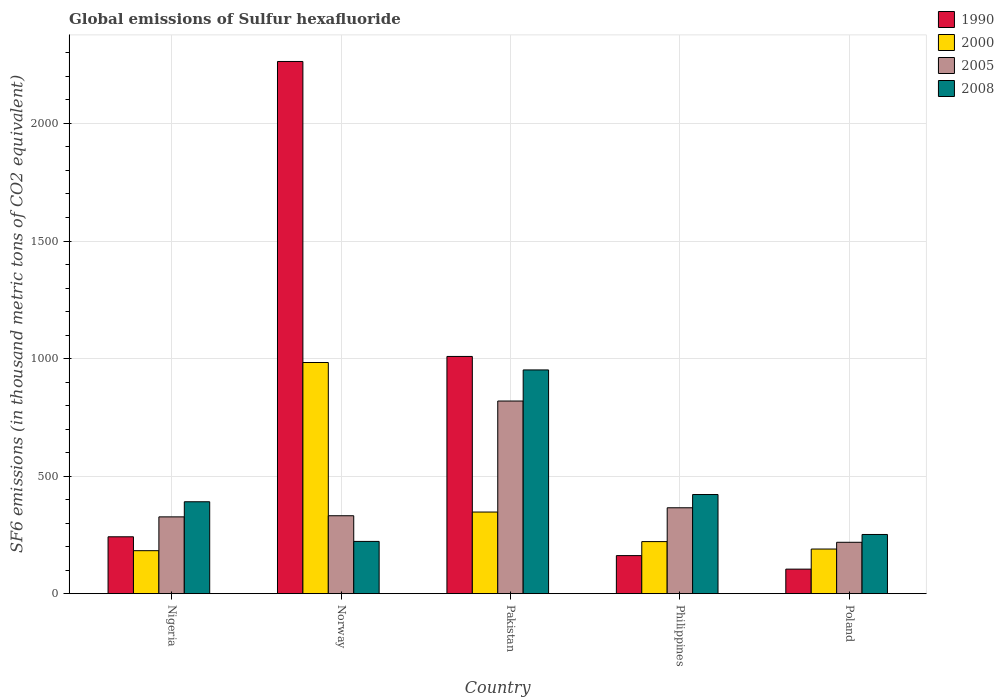How many different coloured bars are there?
Ensure brevity in your answer.  4. How many groups of bars are there?
Your response must be concise. 5. Are the number of bars per tick equal to the number of legend labels?
Give a very brief answer. Yes. Are the number of bars on each tick of the X-axis equal?
Ensure brevity in your answer.  Yes. How many bars are there on the 1st tick from the right?
Give a very brief answer. 4. What is the label of the 4th group of bars from the left?
Give a very brief answer. Philippines. What is the global emissions of Sulfur hexafluoride in 2000 in Pakistan?
Your response must be concise. 347.2. Across all countries, what is the maximum global emissions of Sulfur hexafluoride in 2008?
Make the answer very short. 951.6. Across all countries, what is the minimum global emissions of Sulfur hexafluoride in 1990?
Your answer should be compact. 104.3. In which country was the global emissions of Sulfur hexafluoride in 2000 minimum?
Make the answer very short. Nigeria. What is the total global emissions of Sulfur hexafluoride in 2005 in the graph?
Provide a short and direct response. 2061.2. What is the difference between the global emissions of Sulfur hexafluoride in 2000 in Nigeria and that in Norway?
Your response must be concise. -800.4. What is the difference between the global emissions of Sulfur hexafluoride in 2000 in Poland and the global emissions of Sulfur hexafluoride in 1990 in Philippines?
Provide a short and direct response. 27.9. What is the average global emissions of Sulfur hexafluoride in 2000 per country?
Your response must be concise. 384.88. What is the difference between the global emissions of Sulfur hexafluoride of/in 2005 and global emissions of Sulfur hexafluoride of/in 2000 in Nigeria?
Offer a terse response. 143.8. In how many countries, is the global emissions of Sulfur hexafluoride in 2008 greater than 200 thousand metric tons?
Make the answer very short. 5. What is the ratio of the global emissions of Sulfur hexafluoride in 2005 in Pakistan to that in Philippines?
Ensure brevity in your answer.  2.24. Is the global emissions of Sulfur hexafluoride in 1990 in Nigeria less than that in Poland?
Give a very brief answer. No. What is the difference between the highest and the second highest global emissions of Sulfur hexafluoride in 2005?
Your answer should be compact. -488. What is the difference between the highest and the lowest global emissions of Sulfur hexafluoride in 2000?
Your response must be concise. 800.4. In how many countries, is the global emissions of Sulfur hexafluoride in 1990 greater than the average global emissions of Sulfur hexafluoride in 1990 taken over all countries?
Offer a terse response. 2. Is the sum of the global emissions of Sulfur hexafluoride in 1990 in Norway and Philippines greater than the maximum global emissions of Sulfur hexafluoride in 2000 across all countries?
Give a very brief answer. Yes. Is it the case that in every country, the sum of the global emissions of Sulfur hexafluoride in 2005 and global emissions of Sulfur hexafluoride in 1990 is greater than the sum of global emissions of Sulfur hexafluoride in 2008 and global emissions of Sulfur hexafluoride in 2000?
Your response must be concise. No. What does the 2nd bar from the left in Poland represents?
Keep it short and to the point. 2000. What does the 4th bar from the right in Philippines represents?
Provide a succinct answer. 1990. Is it the case that in every country, the sum of the global emissions of Sulfur hexafluoride in 2005 and global emissions of Sulfur hexafluoride in 2000 is greater than the global emissions of Sulfur hexafluoride in 1990?
Give a very brief answer. No. How many bars are there?
Offer a terse response. 20. Does the graph contain grids?
Offer a terse response. Yes. What is the title of the graph?
Offer a terse response. Global emissions of Sulfur hexafluoride. What is the label or title of the Y-axis?
Keep it short and to the point. SF6 emissions (in thousand metric tons of CO2 equivalent). What is the SF6 emissions (in thousand metric tons of CO2 equivalent) of 1990 in Nigeria?
Provide a succinct answer. 241.9. What is the SF6 emissions (in thousand metric tons of CO2 equivalent) of 2000 in Nigeria?
Provide a succinct answer. 182.8. What is the SF6 emissions (in thousand metric tons of CO2 equivalent) in 2005 in Nigeria?
Your answer should be very brief. 326.6. What is the SF6 emissions (in thousand metric tons of CO2 equivalent) in 2008 in Nigeria?
Provide a succinct answer. 390.9. What is the SF6 emissions (in thousand metric tons of CO2 equivalent) of 1990 in Norway?
Provide a short and direct response. 2263.6. What is the SF6 emissions (in thousand metric tons of CO2 equivalent) in 2000 in Norway?
Your response must be concise. 983.2. What is the SF6 emissions (in thousand metric tons of CO2 equivalent) of 2005 in Norway?
Offer a very short reply. 331.4. What is the SF6 emissions (in thousand metric tons of CO2 equivalent) in 2008 in Norway?
Provide a short and direct response. 222.2. What is the SF6 emissions (in thousand metric tons of CO2 equivalent) of 1990 in Pakistan?
Make the answer very short. 1009. What is the SF6 emissions (in thousand metric tons of CO2 equivalent) in 2000 in Pakistan?
Ensure brevity in your answer.  347.2. What is the SF6 emissions (in thousand metric tons of CO2 equivalent) of 2005 in Pakistan?
Provide a short and direct response. 819.4. What is the SF6 emissions (in thousand metric tons of CO2 equivalent) in 2008 in Pakistan?
Provide a succinct answer. 951.6. What is the SF6 emissions (in thousand metric tons of CO2 equivalent) of 1990 in Philippines?
Ensure brevity in your answer.  161.9. What is the SF6 emissions (in thousand metric tons of CO2 equivalent) of 2000 in Philippines?
Keep it short and to the point. 221.4. What is the SF6 emissions (in thousand metric tons of CO2 equivalent) of 2005 in Philippines?
Provide a succinct answer. 365.3. What is the SF6 emissions (in thousand metric tons of CO2 equivalent) of 2008 in Philippines?
Give a very brief answer. 421.7. What is the SF6 emissions (in thousand metric tons of CO2 equivalent) in 1990 in Poland?
Your response must be concise. 104.3. What is the SF6 emissions (in thousand metric tons of CO2 equivalent) in 2000 in Poland?
Make the answer very short. 189.8. What is the SF6 emissions (in thousand metric tons of CO2 equivalent) in 2005 in Poland?
Your response must be concise. 218.5. What is the SF6 emissions (in thousand metric tons of CO2 equivalent) in 2008 in Poland?
Your answer should be very brief. 251.7. Across all countries, what is the maximum SF6 emissions (in thousand metric tons of CO2 equivalent) in 1990?
Keep it short and to the point. 2263.6. Across all countries, what is the maximum SF6 emissions (in thousand metric tons of CO2 equivalent) of 2000?
Keep it short and to the point. 983.2. Across all countries, what is the maximum SF6 emissions (in thousand metric tons of CO2 equivalent) of 2005?
Your answer should be compact. 819.4. Across all countries, what is the maximum SF6 emissions (in thousand metric tons of CO2 equivalent) in 2008?
Ensure brevity in your answer.  951.6. Across all countries, what is the minimum SF6 emissions (in thousand metric tons of CO2 equivalent) of 1990?
Your answer should be compact. 104.3. Across all countries, what is the minimum SF6 emissions (in thousand metric tons of CO2 equivalent) of 2000?
Offer a terse response. 182.8. Across all countries, what is the minimum SF6 emissions (in thousand metric tons of CO2 equivalent) of 2005?
Ensure brevity in your answer.  218.5. Across all countries, what is the minimum SF6 emissions (in thousand metric tons of CO2 equivalent) in 2008?
Give a very brief answer. 222.2. What is the total SF6 emissions (in thousand metric tons of CO2 equivalent) of 1990 in the graph?
Provide a short and direct response. 3780.7. What is the total SF6 emissions (in thousand metric tons of CO2 equivalent) in 2000 in the graph?
Make the answer very short. 1924.4. What is the total SF6 emissions (in thousand metric tons of CO2 equivalent) of 2005 in the graph?
Provide a succinct answer. 2061.2. What is the total SF6 emissions (in thousand metric tons of CO2 equivalent) in 2008 in the graph?
Provide a succinct answer. 2238.1. What is the difference between the SF6 emissions (in thousand metric tons of CO2 equivalent) in 1990 in Nigeria and that in Norway?
Offer a terse response. -2021.7. What is the difference between the SF6 emissions (in thousand metric tons of CO2 equivalent) of 2000 in Nigeria and that in Norway?
Your response must be concise. -800.4. What is the difference between the SF6 emissions (in thousand metric tons of CO2 equivalent) in 2008 in Nigeria and that in Norway?
Provide a succinct answer. 168.7. What is the difference between the SF6 emissions (in thousand metric tons of CO2 equivalent) in 1990 in Nigeria and that in Pakistan?
Keep it short and to the point. -767.1. What is the difference between the SF6 emissions (in thousand metric tons of CO2 equivalent) of 2000 in Nigeria and that in Pakistan?
Offer a very short reply. -164.4. What is the difference between the SF6 emissions (in thousand metric tons of CO2 equivalent) in 2005 in Nigeria and that in Pakistan?
Make the answer very short. -492.8. What is the difference between the SF6 emissions (in thousand metric tons of CO2 equivalent) of 2008 in Nigeria and that in Pakistan?
Offer a terse response. -560.7. What is the difference between the SF6 emissions (in thousand metric tons of CO2 equivalent) of 1990 in Nigeria and that in Philippines?
Your response must be concise. 80. What is the difference between the SF6 emissions (in thousand metric tons of CO2 equivalent) in 2000 in Nigeria and that in Philippines?
Ensure brevity in your answer.  -38.6. What is the difference between the SF6 emissions (in thousand metric tons of CO2 equivalent) in 2005 in Nigeria and that in Philippines?
Offer a terse response. -38.7. What is the difference between the SF6 emissions (in thousand metric tons of CO2 equivalent) in 2008 in Nigeria and that in Philippines?
Your answer should be compact. -30.8. What is the difference between the SF6 emissions (in thousand metric tons of CO2 equivalent) in 1990 in Nigeria and that in Poland?
Keep it short and to the point. 137.6. What is the difference between the SF6 emissions (in thousand metric tons of CO2 equivalent) in 2005 in Nigeria and that in Poland?
Your answer should be compact. 108.1. What is the difference between the SF6 emissions (in thousand metric tons of CO2 equivalent) of 2008 in Nigeria and that in Poland?
Offer a very short reply. 139.2. What is the difference between the SF6 emissions (in thousand metric tons of CO2 equivalent) in 1990 in Norway and that in Pakistan?
Your answer should be very brief. 1254.6. What is the difference between the SF6 emissions (in thousand metric tons of CO2 equivalent) of 2000 in Norway and that in Pakistan?
Keep it short and to the point. 636. What is the difference between the SF6 emissions (in thousand metric tons of CO2 equivalent) in 2005 in Norway and that in Pakistan?
Make the answer very short. -488. What is the difference between the SF6 emissions (in thousand metric tons of CO2 equivalent) in 2008 in Norway and that in Pakistan?
Your answer should be compact. -729.4. What is the difference between the SF6 emissions (in thousand metric tons of CO2 equivalent) of 1990 in Norway and that in Philippines?
Keep it short and to the point. 2101.7. What is the difference between the SF6 emissions (in thousand metric tons of CO2 equivalent) in 2000 in Norway and that in Philippines?
Offer a very short reply. 761.8. What is the difference between the SF6 emissions (in thousand metric tons of CO2 equivalent) of 2005 in Norway and that in Philippines?
Keep it short and to the point. -33.9. What is the difference between the SF6 emissions (in thousand metric tons of CO2 equivalent) in 2008 in Norway and that in Philippines?
Your response must be concise. -199.5. What is the difference between the SF6 emissions (in thousand metric tons of CO2 equivalent) in 1990 in Norway and that in Poland?
Your response must be concise. 2159.3. What is the difference between the SF6 emissions (in thousand metric tons of CO2 equivalent) in 2000 in Norway and that in Poland?
Make the answer very short. 793.4. What is the difference between the SF6 emissions (in thousand metric tons of CO2 equivalent) of 2005 in Norway and that in Poland?
Offer a terse response. 112.9. What is the difference between the SF6 emissions (in thousand metric tons of CO2 equivalent) in 2008 in Norway and that in Poland?
Give a very brief answer. -29.5. What is the difference between the SF6 emissions (in thousand metric tons of CO2 equivalent) in 1990 in Pakistan and that in Philippines?
Your response must be concise. 847.1. What is the difference between the SF6 emissions (in thousand metric tons of CO2 equivalent) in 2000 in Pakistan and that in Philippines?
Offer a very short reply. 125.8. What is the difference between the SF6 emissions (in thousand metric tons of CO2 equivalent) in 2005 in Pakistan and that in Philippines?
Make the answer very short. 454.1. What is the difference between the SF6 emissions (in thousand metric tons of CO2 equivalent) in 2008 in Pakistan and that in Philippines?
Offer a terse response. 529.9. What is the difference between the SF6 emissions (in thousand metric tons of CO2 equivalent) in 1990 in Pakistan and that in Poland?
Your answer should be very brief. 904.7. What is the difference between the SF6 emissions (in thousand metric tons of CO2 equivalent) of 2000 in Pakistan and that in Poland?
Offer a very short reply. 157.4. What is the difference between the SF6 emissions (in thousand metric tons of CO2 equivalent) of 2005 in Pakistan and that in Poland?
Provide a succinct answer. 600.9. What is the difference between the SF6 emissions (in thousand metric tons of CO2 equivalent) of 2008 in Pakistan and that in Poland?
Provide a succinct answer. 699.9. What is the difference between the SF6 emissions (in thousand metric tons of CO2 equivalent) in 1990 in Philippines and that in Poland?
Give a very brief answer. 57.6. What is the difference between the SF6 emissions (in thousand metric tons of CO2 equivalent) of 2000 in Philippines and that in Poland?
Ensure brevity in your answer.  31.6. What is the difference between the SF6 emissions (in thousand metric tons of CO2 equivalent) in 2005 in Philippines and that in Poland?
Offer a very short reply. 146.8. What is the difference between the SF6 emissions (in thousand metric tons of CO2 equivalent) of 2008 in Philippines and that in Poland?
Keep it short and to the point. 170. What is the difference between the SF6 emissions (in thousand metric tons of CO2 equivalent) of 1990 in Nigeria and the SF6 emissions (in thousand metric tons of CO2 equivalent) of 2000 in Norway?
Give a very brief answer. -741.3. What is the difference between the SF6 emissions (in thousand metric tons of CO2 equivalent) of 1990 in Nigeria and the SF6 emissions (in thousand metric tons of CO2 equivalent) of 2005 in Norway?
Your response must be concise. -89.5. What is the difference between the SF6 emissions (in thousand metric tons of CO2 equivalent) of 2000 in Nigeria and the SF6 emissions (in thousand metric tons of CO2 equivalent) of 2005 in Norway?
Your answer should be compact. -148.6. What is the difference between the SF6 emissions (in thousand metric tons of CO2 equivalent) of 2000 in Nigeria and the SF6 emissions (in thousand metric tons of CO2 equivalent) of 2008 in Norway?
Offer a very short reply. -39.4. What is the difference between the SF6 emissions (in thousand metric tons of CO2 equivalent) of 2005 in Nigeria and the SF6 emissions (in thousand metric tons of CO2 equivalent) of 2008 in Norway?
Your answer should be very brief. 104.4. What is the difference between the SF6 emissions (in thousand metric tons of CO2 equivalent) in 1990 in Nigeria and the SF6 emissions (in thousand metric tons of CO2 equivalent) in 2000 in Pakistan?
Provide a succinct answer. -105.3. What is the difference between the SF6 emissions (in thousand metric tons of CO2 equivalent) of 1990 in Nigeria and the SF6 emissions (in thousand metric tons of CO2 equivalent) of 2005 in Pakistan?
Ensure brevity in your answer.  -577.5. What is the difference between the SF6 emissions (in thousand metric tons of CO2 equivalent) of 1990 in Nigeria and the SF6 emissions (in thousand metric tons of CO2 equivalent) of 2008 in Pakistan?
Make the answer very short. -709.7. What is the difference between the SF6 emissions (in thousand metric tons of CO2 equivalent) of 2000 in Nigeria and the SF6 emissions (in thousand metric tons of CO2 equivalent) of 2005 in Pakistan?
Your answer should be very brief. -636.6. What is the difference between the SF6 emissions (in thousand metric tons of CO2 equivalent) in 2000 in Nigeria and the SF6 emissions (in thousand metric tons of CO2 equivalent) in 2008 in Pakistan?
Your answer should be very brief. -768.8. What is the difference between the SF6 emissions (in thousand metric tons of CO2 equivalent) of 2005 in Nigeria and the SF6 emissions (in thousand metric tons of CO2 equivalent) of 2008 in Pakistan?
Keep it short and to the point. -625. What is the difference between the SF6 emissions (in thousand metric tons of CO2 equivalent) in 1990 in Nigeria and the SF6 emissions (in thousand metric tons of CO2 equivalent) in 2005 in Philippines?
Provide a succinct answer. -123.4. What is the difference between the SF6 emissions (in thousand metric tons of CO2 equivalent) of 1990 in Nigeria and the SF6 emissions (in thousand metric tons of CO2 equivalent) of 2008 in Philippines?
Provide a short and direct response. -179.8. What is the difference between the SF6 emissions (in thousand metric tons of CO2 equivalent) of 2000 in Nigeria and the SF6 emissions (in thousand metric tons of CO2 equivalent) of 2005 in Philippines?
Offer a very short reply. -182.5. What is the difference between the SF6 emissions (in thousand metric tons of CO2 equivalent) in 2000 in Nigeria and the SF6 emissions (in thousand metric tons of CO2 equivalent) in 2008 in Philippines?
Offer a terse response. -238.9. What is the difference between the SF6 emissions (in thousand metric tons of CO2 equivalent) in 2005 in Nigeria and the SF6 emissions (in thousand metric tons of CO2 equivalent) in 2008 in Philippines?
Your response must be concise. -95.1. What is the difference between the SF6 emissions (in thousand metric tons of CO2 equivalent) in 1990 in Nigeria and the SF6 emissions (in thousand metric tons of CO2 equivalent) in 2000 in Poland?
Provide a short and direct response. 52.1. What is the difference between the SF6 emissions (in thousand metric tons of CO2 equivalent) in 1990 in Nigeria and the SF6 emissions (in thousand metric tons of CO2 equivalent) in 2005 in Poland?
Ensure brevity in your answer.  23.4. What is the difference between the SF6 emissions (in thousand metric tons of CO2 equivalent) in 1990 in Nigeria and the SF6 emissions (in thousand metric tons of CO2 equivalent) in 2008 in Poland?
Give a very brief answer. -9.8. What is the difference between the SF6 emissions (in thousand metric tons of CO2 equivalent) in 2000 in Nigeria and the SF6 emissions (in thousand metric tons of CO2 equivalent) in 2005 in Poland?
Make the answer very short. -35.7. What is the difference between the SF6 emissions (in thousand metric tons of CO2 equivalent) of 2000 in Nigeria and the SF6 emissions (in thousand metric tons of CO2 equivalent) of 2008 in Poland?
Offer a terse response. -68.9. What is the difference between the SF6 emissions (in thousand metric tons of CO2 equivalent) of 2005 in Nigeria and the SF6 emissions (in thousand metric tons of CO2 equivalent) of 2008 in Poland?
Your answer should be very brief. 74.9. What is the difference between the SF6 emissions (in thousand metric tons of CO2 equivalent) in 1990 in Norway and the SF6 emissions (in thousand metric tons of CO2 equivalent) in 2000 in Pakistan?
Your answer should be very brief. 1916.4. What is the difference between the SF6 emissions (in thousand metric tons of CO2 equivalent) of 1990 in Norway and the SF6 emissions (in thousand metric tons of CO2 equivalent) of 2005 in Pakistan?
Provide a succinct answer. 1444.2. What is the difference between the SF6 emissions (in thousand metric tons of CO2 equivalent) of 1990 in Norway and the SF6 emissions (in thousand metric tons of CO2 equivalent) of 2008 in Pakistan?
Make the answer very short. 1312. What is the difference between the SF6 emissions (in thousand metric tons of CO2 equivalent) in 2000 in Norway and the SF6 emissions (in thousand metric tons of CO2 equivalent) in 2005 in Pakistan?
Give a very brief answer. 163.8. What is the difference between the SF6 emissions (in thousand metric tons of CO2 equivalent) of 2000 in Norway and the SF6 emissions (in thousand metric tons of CO2 equivalent) of 2008 in Pakistan?
Your response must be concise. 31.6. What is the difference between the SF6 emissions (in thousand metric tons of CO2 equivalent) in 2005 in Norway and the SF6 emissions (in thousand metric tons of CO2 equivalent) in 2008 in Pakistan?
Ensure brevity in your answer.  -620.2. What is the difference between the SF6 emissions (in thousand metric tons of CO2 equivalent) in 1990 in Norway and the SF6 emissions (in thousand metric tons of CO2 equivalent) in 2000 in Philippines?
Give a very brief answer. 2042.2. What is the difference between the SF6 emissions (in thousand metric tons of CO2 equivalent) of 1990 in Norway and the SF6 emissions (in thousand metric tons of CO2 equivalent) of 2005 in Philippines?
Give a very brief answer. 1898.3. What is the difference between the SF6 emissions (in thousand metric tons of CO2 equivalent) of 1990 in Norway and the SF6 emissions (in thousand metric tons of CO2 equivalent) of 2008 in Philippines?
Keep it short and to the point. 1841.9. What is the difference between the SF6 emissions (in thousand metric tons of CO2 equivalent) of 2000 in Norway and the SF6 emissions (in thousand metric tons of CO2 equivalent) of 2005 in Philippines?
Give a very brief answer. 617.9. What is the difference between the SF6 emissions (in thousand metric tons of CO2 equivalent) in 2000 in Norway and the SF6 emissions (in thousand metric tons of CO2 equivalent) in 2008 in Philippines?
Your answer should be compact. 561.5. What is the difference between the SF6 emissions (in thousand metric tons of CO2 equivalent) of 2005 in Norway and the SF6 emissions (in thousand metric tons of CO2 equivalent) of 2008 in Philippines?
Your response must be concise. -90.3. What is the difference between the SF6 emissions (in thousand metric tons of CO2 equivalent) in 1990 in Norway and the SF6 emissions (in thousand metric tons of CO2 equivalent) in 2000 in Poland?
Provide a short and direct response. 2073.8. What is the difference between the SF6 emissions (in thousand metric tons of CO2 equivalent) in 1990 in Norway and the SF6 emissions (in thousand metric tons of CO2 equivalent) in 2005 in Poland?
Make the answer very short. 2045.1. What is the difference between the SF6 emissions (in thousand metric tons of CO2 equivalent) in 1990 in Norway and the SF6 emissions (in thousand metric tons of CO2 equivalent) in 2008 in Poland?
Your answer should be very brief. 2011.9. What is the difference between the SF6 emissions (in thousand metric tons of CO2 equivalent) in 2000 in Norway and the SF6 emissions (in thousand metric tons of CO2 equivalent) in 2005 in Poland?
Provide a succinct answer. 764.7. What is the difference between the SF6 emissions (in thousand metric tons of CO2 equivalent) of 2000 in Norway and the SF6 emissions (in thousand metric tons of CO2 equivalent) of 2008 in Poland?
Provide a short and direct response. 731.5. What is the difference between the SF6 emissions (in thousand metric tons of CO2 equivalent) in 2005 in Norway and the SF6 emissions (in thousand metric tons of CO2 equivalent) in 2008 in Poland?
Make the answer very short. 79.7. What is the difference between the SF6 emissions (in thousand metric tons of CO2 equivalent) of 1990 in Pakistan and the SF6 emissions (in thousand metric tons of CO2 equivalent) of 2000 in Philippines?
Offer a terse response. 787.6. What is the difference between the SF6 emissions (in thousand metric tons of CO2 equivalent) of 1990 in Pakistan and the SF6 emissions (in thousand metric tons of CO2 equivalent) of 2005 in Philippines?
Your answer should be compact. 643.7. What is the difference between the SF6 emissions (in thousand metric tons of CO2 equivalent) in 1990 in Pakistan and the SF6 emissions (in thousand metric tons of CO2 equivalent) in 2008 in Philippines?
Provide a short and direct response. 587.3. What is the difference between the SF6 emissions (in thousand metric tons of CO2 equivalent) of 2000 in Pakistan and the SF6 emissions (in thousand metric tons of CO2 equivalent) of 2005 in Philippines?
Offer a very short reply. -18.1. What is the difference between the SF6 emissions (in thousand metric tons of CO2 equivalent) of 2000 in Pakistan and the SF6 emissions (in thousand metric tons of CO2 equivalent) of 2008 in Philippines?
Provide a succinct answer. -74.5. What is the difference between the SF6 emissions (in thousand metric tons of CO2 equivalent) of 2005 in Pakistan and the SF6 emissions (in thousand metric tons of CO2 equivalent) of 2008 in Philippines?
Keep it short and to the point. 397.7. What is the difference between the SF6 emissions (in thousand metric tons of CO2 equivalent) of 1990 in Pakistan and the SF6 emissions (in thousand metric tons of CO2 equivalent) of 2000 in Poland?
Give a very brief answer. 819.2. What is the difference between the SF6 emissions (in thousand metric tons of CO2 equivalent) of 1990 in Pakistan and the SF6 emissions (in thousand metric tons of CO2 equivalent) of 2005 in Poland?
Provide a short and direct response. 790.5. What is the difference between the SF6 emissions (in thousand metric tons of CO2 equivalent) in 1990 in Pakistan and the SF6 emissions (in thousand metric tons of CO2 equivalent) in 2008 in Poland?
Provide a succinct answer. 757.3. What is the difference between the SF6 emissions (in thousand metric tons of CO2 equivalent) in 2000 in Pakistan and the SF6 emissions (in thousand metric tons of CO2 equivalent) in 2005 in Poland?
Offer a terse response. 128.7. What is the difference between the SF6 emissions (in thousand metric tons of CO2 equivalent) of 2000 in Pakistan and the SF6 emissions (in thousand metric tons of CO2 equivalent) of 2008 in Poland?
Offer a very short reply. 95.5. What is the difference between the SF6 emissions (in thousand metric tons of CO2 equivalent) in 2005 in Pakistan and the SF6 emissions (in thousand metric tons of CO2 equivalent) in 2008 in Poland?
Your answer should be compact. 567.7. What is the difference between the SF6 emissions (in thousand metric tons of CO2 equivalent) of 1990 in Philippines and the SF6 emissions (in thousand metric tons of CO2 equivalent) of 2000 in Poland?
Provide a short and direct response. -27.9. What is the difference between the SF6 emissions (in thousand metric tons of CO2 equivalent) in 1990 in Philippines and the SF6 emissions (in thousand metric tons of CO2 equivalent) in 2005 in Poland?
Offer a terse response. -56.6. What is the difference between the SF6 emissions (in thousand metric tons of CO2 equivalent) in 1990 in Philippines and the SF6 emissions (in thousand metric tons of CO2 equivalent) in 2008 in Poland?
Ensure brevity in your answer.  -89.8. What is the difference between the SF6 emissions (in thousand metric tons of CO2 equivalent) of 2000 in Philippines and the SF6 emissions (in thousand metric tons of CO2 equivalent) of 2008 in Poland?
Your answer should be very brief. -30.3. What is the difference between the SF6 emissions (in thousand metric tons of CO2 equivalent) of 2005 in Philippines and the SF6 emissions (in thousand metric tons of CO2 equivalent) of 2008 in Poland?
Give a very brief answer. 113.6. What is the average SF6 emissions (in thousand metric tons of CO2 equivalent) of 1990 per country?
Make the answer very short. 756.14. What is the average SF6 emissions (in thousand metric tons of CO2 equivalent) in 2000 per country?
Ensure brevity in your answer.  384.88. What is the average SF6 emissions (in thousand metric tons of CO2 equivalent) of 2005 per country?
Your answer should be very brief. 412.24. What is the average SF6 emissions (in thousand metric tons of CO2 equivalent) in 2008 per country?
Offer a very short reply. 447.62. What is the difference between the SF6 emissions (in thousand metric tons of CO2 equivalent) in 1990 and SF6 emissions (in thousand metric tons of CO2 equivalent) in 2000 in Nigeria?
Make the answer very short. 59.1. What is the difference between the SF6 emissions (in thousand metric tons of CO2 equivalent) in 1990 and SF6 emissions (in thousand metric tons of CO2 equivalent) in 2005 in Nigeria?
Provide a short and direct response. -84.7. What is the difference between the SF6 emissions (in thousand metric tons of CO2 equivalent) in 1990 and SF6 emissions (in thousand metric tons of CO2 equivalent) in 2008 in Nigeria?
Provide a succinct answer. -149. What is the difference between the SF6 emissions (in thousand metric tons of CO2 equivalent) in 2000 and SF6 emissions (in thousand metric tons of CO2 equivalent) in 2005 in Nigeria?
Provide a short and direct response. -143.8. What is the difference between the SF6 emissions (in thousand metric tons of CO2 equivalent) in 2000 and SF6 emissions (in thousand metric tons of CO2 equivalent) in 2008 in Nigeria?
Provide a short and direct response. -208.1. What is the difference between the SF6 emissions (in thousand metric tons of CO2 equivalent) of 2005 and SF6 emissions (in thousand metric tons of CO2 equivalent) of 2008 in Nigeria?
Your answer should be compact. -64.3. What is the difference between the SF6 emissions (in thousand metric tons of CO2 equivalent) of 1990 and SF6 emissions (in thousand metric tons of CO2 equivalent) of 2000 in Norway?
Offer a very short reply. 1280.4. What is the difference between the SF6 emissions (in thousand metric tons of CO2 equivalent) in 1990 and SF6 emissions (in thousand metric tons of CO2 equivalent) in 2005 in Norway?
Provide a succinct answer. 1932.2. What is the difference between the SF6 emissions (in thousand metric tons of CO2 equivalent) of 1990 and SF6 emissions (in thousand metric tons of CO2 equivalent) of 2008 in Norway?
Provide a short and direct response. 2041.4. What is the difference between the SF6 emissions (in thousand metric tons of CO2 equivalent) in 2000 and SF6 emissions (in thousand metric tons of CO2 equivalent) in 2005 in Norway?
Provide a short and direct response. 651.8. What is the difference between the SF6 emissions (in thousand metric tons of CO2 equivalent) in 2000 and SF6 emissions (in thousand metric tons of CO2 equivalent) in 2008 in Norway?
Offer a terse response. 761. What is the difference between the SF6 emissions (in thousand metric tons of CO2 equivalent) of 2005 and SF6 emissions (in thousand metric tons of CO2 equivalent) of 2008 in Norway?
Your response must be concise. 109.2. What is the difference between the SF6 emissions (in thousand metric tons of CO2 equivalent) in 1990 and SF6 emissions (in thousand metric tons of CO2 equivalent) in 2000 in Pakistan?
Keep it short and to the point. 661.8. What is the difference between the SF6 emissions (in thousand metric tons of CO2 equivalent) in 1990 and SF6 emissions (in thousand metric tons of CO2 equivalent) in 2005 in Pakistan?
Offer a terse response. 189.6. What is the difference between the SF6 emissions (in thousand metric tons of CO2 equivalent) of 1990 and SF6 emissions (in thousand metric tons of CO2 equivalent) of 2008 in Pakistan?
Ensure brevity in your answer.  57.4. What is the difference between the SF6 emissions (in thousand metric tons of CO2 equivalent) of 2000 and SF6 emissions (in thousand metric tons of CO2 equivalent) of 2005 in Pakistan?
Offer a very short reply. -472.2. What is the difference between the SF6 emissions (in thousand metric tons of CO2 equivalent) in 2000 and SF6 emissions (in thousand metric tons of CO2 equivalent) in 2008 in Pakistan?
Your response must be concise. -604.4. What is the difference between the SF6 emissions (in thousand metric tons of CO2 equivalent) of 2005 and SF6 emissions (in thousand metric tons of CO2 equivalent) of 2008 in Pakistan?
Provide a short and direct response. -132.2. What is the difference between the SF6 emissions (in thousand metric tons of CO2 equivalent) in 1990 and SF6 emissions (in thousand metric tons of CO2 equivalent) in 2000 in Philippines?
Offer a very short reply. -59.5. What is the difference between the SF6 emissions (in thousand metric tons of CO2 equivalent) of 1990 and SF6 emissions (in thousand metric tons of CO2 equivalent) of 2005 in Philippines?
Make the answer very short. -203.4. What is the difference between the SF6 emissions (in thousand metric tons of CO2 equivalent) of 1990 and SF6 emissions (in thousand metric tons of CO2 equivalent) of 2008 in Philippines?
Offer a very short reply. -259.8. What is the difference between the SF6 emissions (in thousand metric tons of CO2 equivalent) of 2000 and SF6 emissions (in thousand metric tons of CO2 equivalent) of 2005 in Philippines?
Ensure brevity in your answer.  -143.9. What is the difference between the SF6 emissions (in thousand metric tons of CO2 equivalent) of 2000 and SF6 emissions (in thousand metric tons of CO2 equivalent) of 2008 in Philippines?
Offer a very short reply. -200.3. What is the difference between the SF6 emissions (in thousand metric tons of CO2 equivalent) in 2005 and SF6 emissions (in thousand metric tons of CO2 equivalent) in 2008 in Philippines?
Keep it short and to the point. -56.4. What is the difference between the SF6 emissions (in thousand metric tons of CO2 equivalent) of 1990 and SF6 emissions (in thousand metric tons of CO2 equivalent) of 2000 in Poland?
Provide a succinct answer. -85.5. What is the difference between the SF6 emissions (in thousand metric tons of CO2 equivalent) in 1990 and SF6 emissions (in thousand metric tons of CO2 equivalent) in 2005 in Poland?
Your response must be concise. -114.2. What is the difference between the SF6 emissions (in thousand metric tons of CO2 equivalent) of 1990 and SF6 emissions (in thousand metric tons of CO2 equivalent) of 2008 in Poland?
Provide a short and direct response. -147.4. What is the difference between the SF6 emissions (in thousand metric tons of CO2 equivalent) in 2000 and SF6 emissions (in thousand metric tons of CO2 equivalent) in 2005 in Poland?
Your response must be concise. -28.7. What is the difference between the SF6 emissions (in thousand metric tons of CO2 equivalent) of 2000 and SF6 emissions (in thousand metric tons of CO2 equivalent) of 2008 in Poland?
Your answer should be compact. -61.9. What is the difference between the SF6 emissions (in thousand metric tons of CO2 equivalent) in 2005 and SF6 emissions (in thousand metric tons of CO2 equivalent) in 2008 in Poland?
Ensure brevity in your answer.  -33.2. What is the ratio of the SF6 emissions (in thousand metric tons of CO2 equivalent) in 1990 in Nigeria to that in Norway?
Provide a short and direct response. 0.11. What is the ratio of the SF6 emissions (in thousand metric tons of CO2 equivalent) in 2000 in Nigeria to that in Norway?
Your response must be concise. 0.19. What is the ratio of the SF6 emissions (in thousand metric tons of CO2 equivalent) in 2005 in Nigeria to that in Norway?
Offer a very short reply. 0.99. What is the ratio of the SF6 emissions (in thousand metric tons of CO2 equivalent) in 2008 in Nigeria to that in Norway?
Your answer should be very brief. 1.76. What is the ratio of the SF6 emissions (in thousand metric tons of CO2 equivalent) in 1990 in Nigeria to that in Pakistan?
Provide a succinct answer. 0.24. What is the ratio of the SF6 emissions (in thousand metric tons of CO2 equivalent) in 2000 in Nigeria to that in Pakistan?
Provide a short and direct response. 0.53. What is the ratio of the SF6 emissions (in thousand metric tons of CO2 equivalent) in 2005 in Nigeria to that in Pakistan?
Your answer should be very brief. 0.4. What is the ratio of the SF6 emissions (in thousand metric tons of CO2 equivalent) in 2008 in Nigeria to that in Pakistan?
Make the answer very short. 0.41. What is the ratio of the SF6 emissions (in thousand metric tons of CO2 equivalent) in 1990 in Nigeria to that in Philippines?
Make the answer very short. 1.49. What is the ratio of the SF6 emissions (in thousand metric tons of CO2 equivalent) in 2000 in Nigeria to that in Philippines?
Provide a short and direct response. 0.83. What is the ratio of the SF6 emissions (in thousand metric tons of CO2 equivalent) in 2005 in Nigeria to that in Philippines?
Offer a very short reply. 0.89. What is the ratio of the SF6 emissions (in thousand metric tons of CO2 equivalent) in 2008 in Nigeria to that in Philippines?
Your answer should be very brief. 0.93. What is the ratio of the SF6 emissions (in thousand metric tons of CO2 equivalent) in 1990 in Nigeria to that in Poland?
Ensure brevity in your answer.  2.32. What is the ratio of the SF6 emissions (in thousand metric tons of CO2 equivalent) of 2000 in Nigeria to that in Poland?
Keep it short and to the point. 0.96. What is the ratio of the SF6 emissions (in thousand metric tons of CO2 equivalent) in 2005 in Nigeria to that in Poland?
Make the answer very short. 1.49. What is the ratio of the SF6 emissions (in thousand metric tons of CO2 equivalent) of 2008 in Nigeria to that in Poland?
Ensure brevity in your answer.  1.55. What is the ratio of the SF6 emissions (in thousand metric tons of CO2 equivalent) in 1990 in Norway to that in Pakistan?
Your response must be concise. 2.24. What is the ratio of the SF6 emissions (in thousand metric tons of CO2 equivalent) of 2000 in Norway to that in Pakistan?
Keep it short and to the point. 2.83. What is the ratio of the SF6 emissions (in thousand metric tons of CO2 equivalent) in 2005 in Norway to that in Pakistan?
Offer a terse response. 0.4. What is the ratio of the SF6 emissions (in thousand metric tons of CO2 equivalent) of 2008 in Norway to that in Pakistan?
Offer a very short reply. 0.23. What is the ratio of the SF6 emissions (in thousand metric tons of CO2 equivalent) in 1990 in Norway to that in Philippines?
Your answer should be very brief. 13.98. What is the ratio of the SF6 emissions (in thousand metric tons of CO2 equivalent) of 2000 in Norway to that in Philippines?
Your response must be concise. 4.44. What is the ratio of the SF6 emissions (in thousand metric tons of CO2 equivalent) in 2005 in Norway to that in Philippines?
Offer a terse response. 0.91. What is the ratio of the SF6 emissions (in thousand metric tons of CO2 equivalent) of 2008 in Norway to that in Philippines?
Provide a short and direct response. 0.53. What is the ratio of the SF6 emissions (in thousand metric tons of CO2 equivalent) of 1990 in Norway to that in Poland?
Offer a terse response. 21.7. What is the ratio of the SF6 emissions (in thousand metric tons of CO2 equivalent) of 2000 in Norway to that in Poland?
Make the answer very short. 5.18. What is the ratio of the SF6 emissions (in thousand metric tons of CO2 equivalent) of 2005 in Norway to that in Poland?
Your answer should be very brief. 1.52. What is the ratio of the SF6 emissions (in thousand metric tons of CO2 equivalent) of 2008 in Norway to that in Poland?
Your answer should be very brief. 0.88. What is the ratio of the SF6 emissions (in thousand metric tons of CO2 equivalent) in 1990 in Pakistan to that in Philippines?
Offer a terse response. 6.23. What is the ratio of the SF6 emissions (in thousand metric tons of CO2 equivalent) of 2000 in Pakistan to that in Philippines?
Offer a terse response. 1.57. What is the ratio of the SF6 emissions (in thousand metric tons of CO2 equivalent) of 2005 in Pakistan to that in Philippines?
Your response must be concise. 2.24. What is the ratio of the SF6 emissions (in thousand metric tons of CO2 equivalent) in 2008 in Pakistan to that in Philippines?
Your answer should be compact. 2.26. What is the ratio of the SF6 emissions (in thousand metric tons of CO2 equivalent) in 1990 in Pakistan to that in Poland?
Keep it short and to the point. 9.67. What is the ratio of the SF6 emissions (in thousand metric tons of CO2 equivalent) of 2000 in Pakistan to that in Poland?
Offer a very short reply. 1.83. What is the ratio of the SF6 emissions (in thousand metric tons of CO2 equivalent) of 2005 in Pakistan to that in Poland?
Offer a very short reply. 3.75. What is the ratio of the SF6 emissions (in thousand metric tons of CO2 equivalent) of 2008 in Pakistan to that in Poland?
Offer a very short reply. 3.78. What is the ratio of the SF6 emissions (in thousand metric tons of CO2 equivalent) in 1990 in Philippines to that in Poland?
Provide a succinct answer. 1.55. What is the ratio of the SF6 emissions (in thousand metric tons of CO2 equivalent) in 2000 in Philippines to that in Poland?
Your answer should be very brief. 1.17. What is the ratio of the SF6 emissions (in thousand metric tons of CO2 equivalent) of 2005 in Philippines to that in Poland?
Your answer should be compact. 1.67. What is the ratio of the SF6 emissions (in thousand metric tons of CO2 equivalent) in 2008 in Philippines to that in Poland?
Provide a succinct answer. 1.68. What is the difference between the highest and the second highest SF6 emissions (in thousand metric tons of CO2 equivalent) of 1990?
Offer a terse response. 1254.6. What is the difference between the highest and the second highest SF6 emissions (in thousand metric tons of CO2 equivalent) of 2000?
Your answer should be compact. 636. What is the difference between the highest and the second highest SF6 emissions (in thousand metric tons of CO2 equivalent) in 2005?
Provide a succinct answer. 454.1. What is the difference between the highest and the second highest SF6 emissions (in thousand metric tons of CO2 equivalent) of 2008?
Give a very brief answer. 529.9. What is the difference between the highest and the lowest SF6 emissions (in thousand metric tons of CO2 equivalent) in 1990?
Make the answer very short. 2159.3. What is the difference between the highest and the lowest SF6 emissions (in thousand metric tons of CO2 equivalent) of 2000?
Provide a succinct answer. 800.4. What is the difference between the highest and the lowest SF6 emissions (in thousand metric tons of CO2 equivalent) of 2005?
Offer a very short reply. 600.9. What is the difference between the highest and the lowest SF6 emissions (in thousand metric tons of CO2 equivalent) in 2008?
Offer a very short reply. 729.4. 